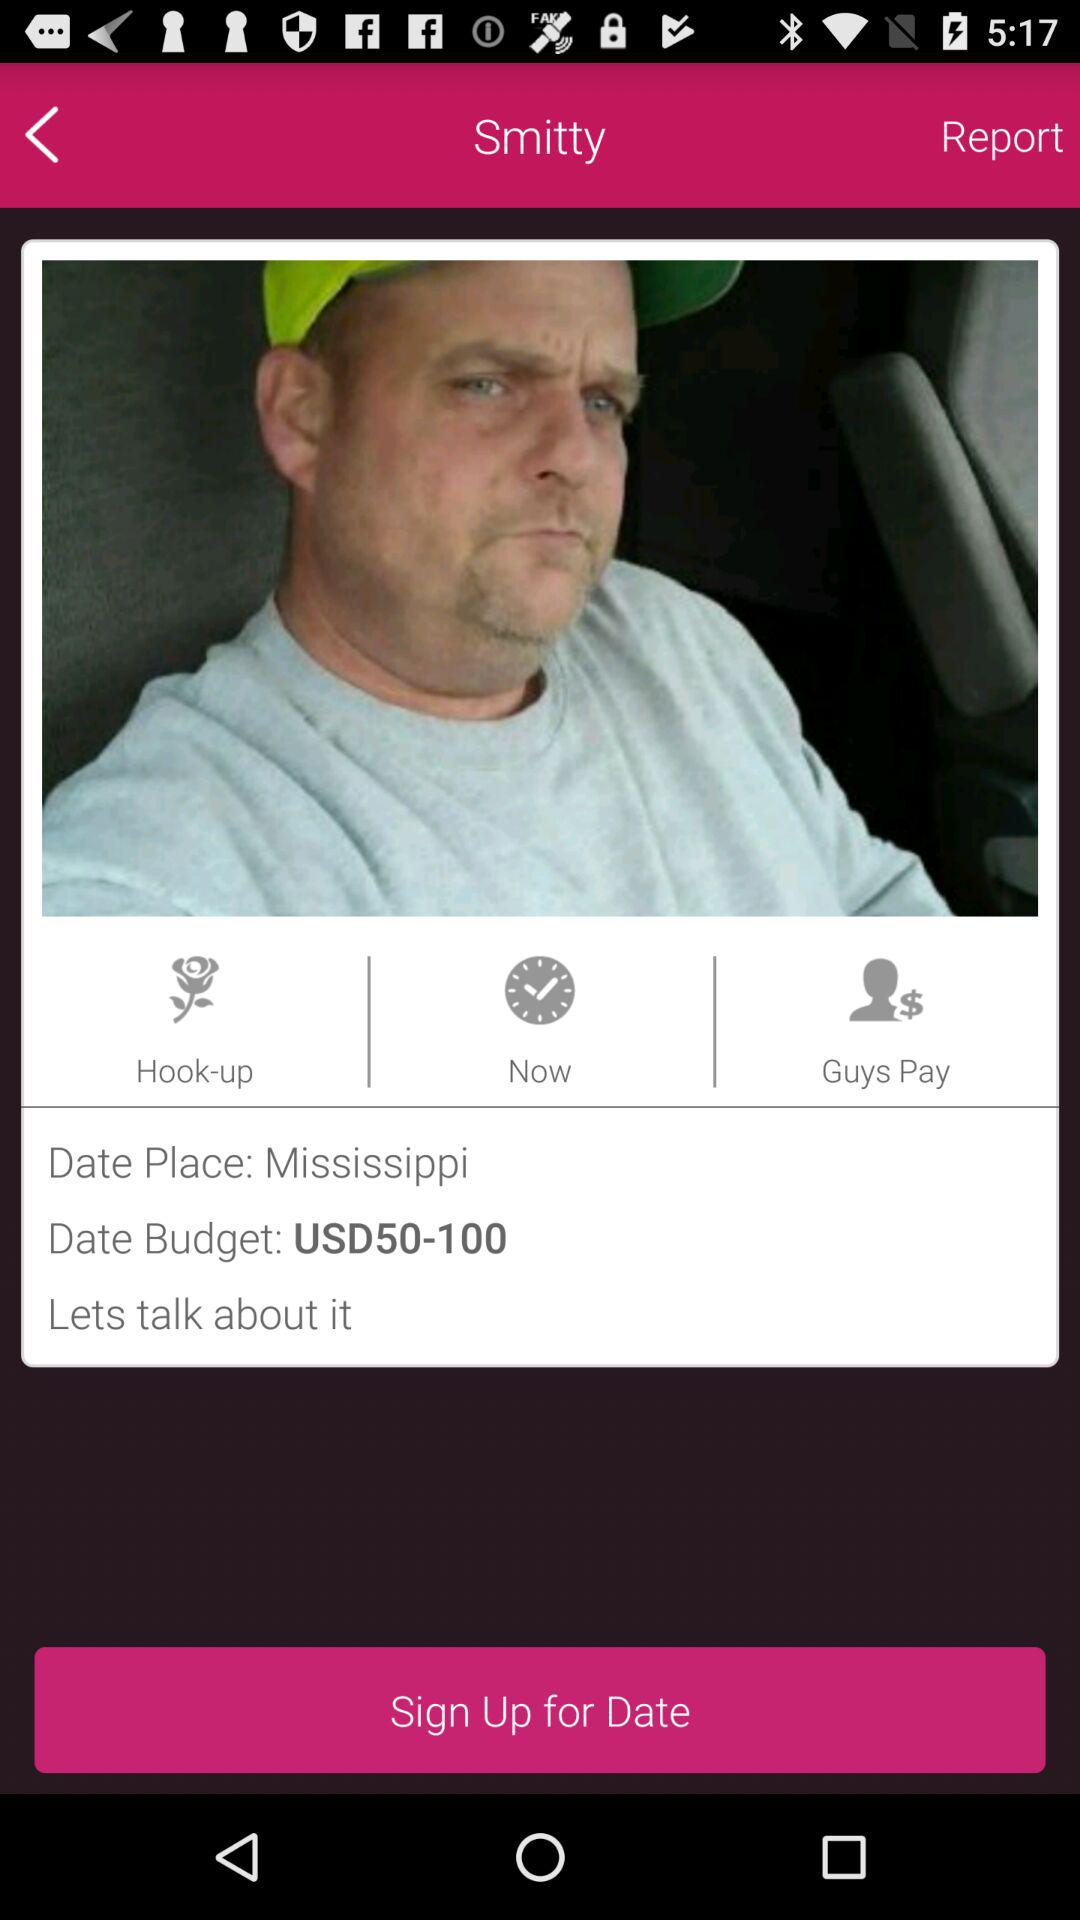What is the "Date Budget"? The "Date Budget" is USD 50–100. 